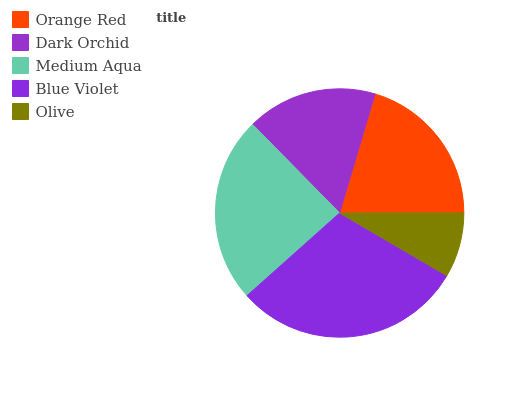Is Olive the minimum?
Answer yes or no. Yes. Is Blue Violet the maximum?
Answer yes or no. Yes. Is Dark Orchid the minimum?
Answer yes or no. No. Is Dark Orchid the maximum?
Answer yes or no. No. Is Orange Red greater than Dark Orchid?
Answer yes or no. Yes. Is Dark Orchid less than Orange Red?
Answer yes or no. Yes. Is Dark Orchid greater than Orange Red?
Answer yes or no. No. Is Orange Red less than Dark Orchid?
Answer yes or no. No. Is Orange Red the high median?
Answer yes or no. Yes. Is Orange Red the low median?
Answer yes or no. Yes. Is Dark Orchid the high median?
Answer yes or no. No. Is Blue Violet the low median?
Answer yes or no. No. 